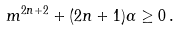Convert formula to latex. <formula><loc_0><loc_0><loc_500><loc_500>m ^ { 2 n + 2 } + ( 2 n + 1 ) \alpha \geq 0 \, .</formula> 